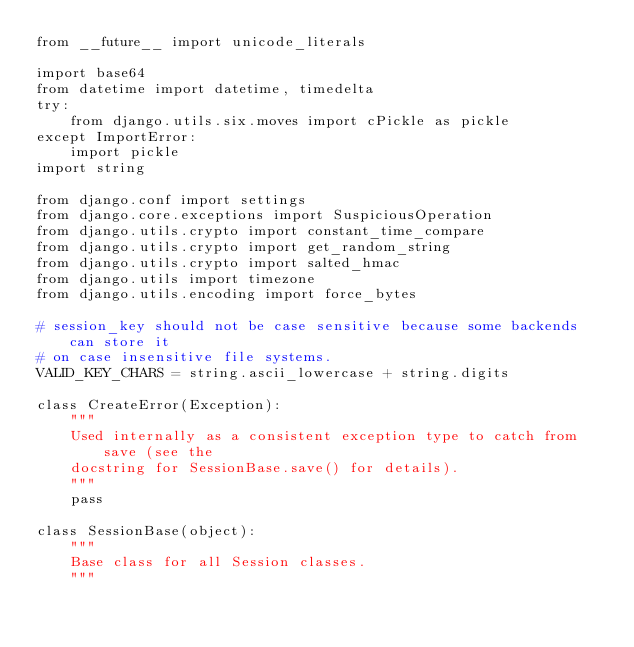Convert code to text. <code><loc_0><loc_0><loc_500><loc_500><_Python_>from __future__ import unicode_literals

import base64
from datetime import datetime, timedelta
try:
    from django.utils.six.moves import cPickle as pickle
except ImportError:
    import pickle
import string

from django.conf import settings
from django.core.exceptions import SuspiciousOperation
from django.utils.crypto import constant_time_compare
from django.utils.crypto import get_random_string
from django.utils.crypto import salted_hmac
from django.utils import timezone
from django.utils.encoding import force_bytes

# session_key should not be case sensitive because some backends can store it
# on case insensitive file systems.
VALID_KEY_CHARS = string.ascii_lowercase + string.digits

class CreateError(Exception):
    """
    Used internally as a consistent exception type to catch from save (see the
    docstring for SessionBase.save() for details).
    """
    pass

class SessionBase(object):
    """
    Base class for all Session classes.
    """</code> 